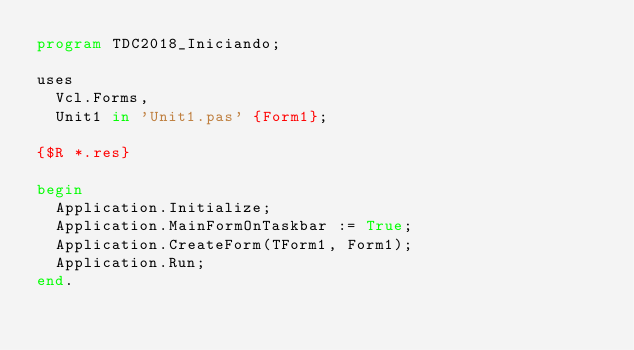<code> <loc_0><loc_0><loc_500><loc_500><_Pascal_>program TDC2018_Iniciando;

uses
  Vcl.Forms,
  Unit1 in 'Unit1.pas' {Form1};

{$R *.res}

begin
  Application.Initialize;
  Application.MainFormOnTaskbar := True;
  Application.CreateForm(TForm1, Form1);
  Application.Run;
end.
</code> 